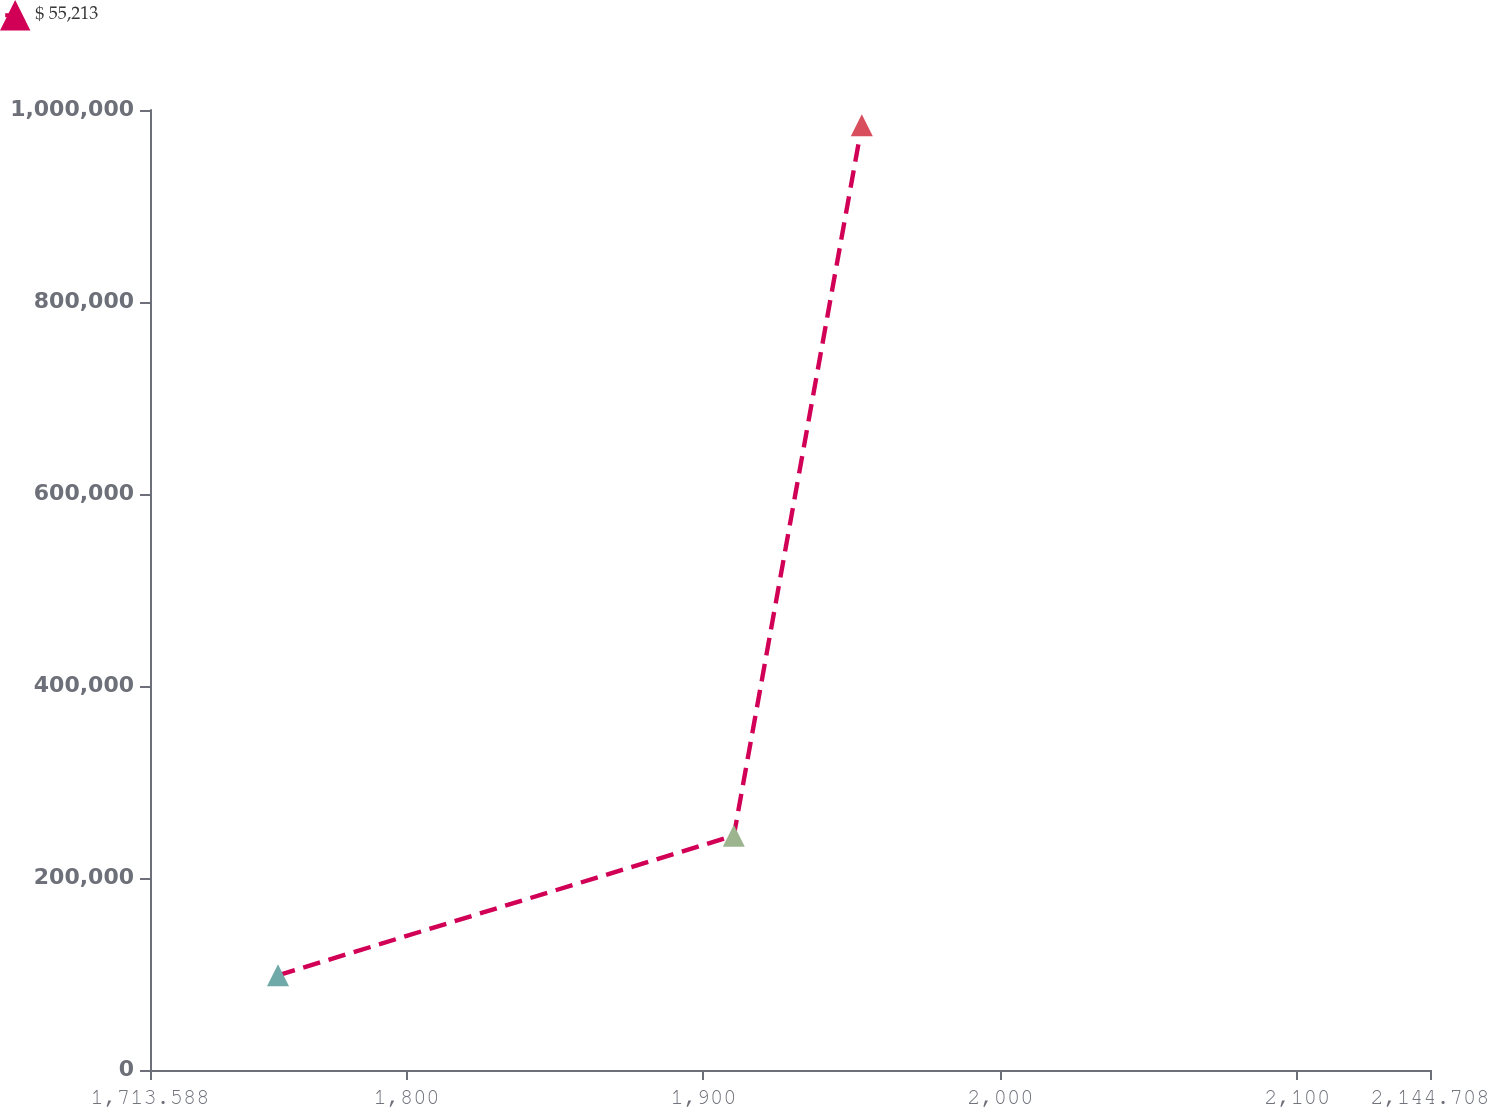Convert chart. <chart><loc_0><loc_0><loc_500><loc_500><line_chart><ecel><fcel>$ 55,213<nl><fcel>1756.7<fcel>98586.3<nl><fcel>1910.23<fcel>244135<nl><fcel>1953.34<fcel>984122<nl><fcel>2187.82<fcel>193.46<nl></chart> 